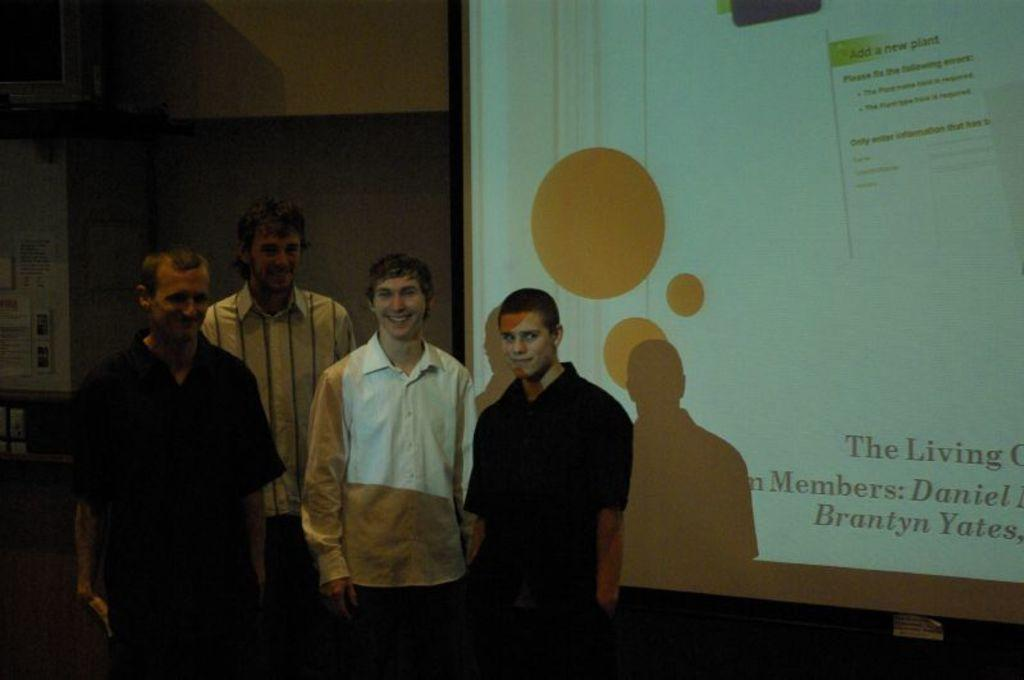How many people are present in the image? There are four people standing in the image. Where are the people located? The people are standing on a path. What is the large, rectangular object in the image? There is a projector screen in the image. What is behind the people in the image? There is a wall behind the people. What type of grain is being harvested in the image? There is no grain or harvesting activity present in the image. How many eggs are visible on the projector screen? There are no eggs visible on the projector screen; it is a large, rectangular object used for displaying images or videos. 